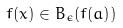Convert formula to latex. <formula><loc_0><loc_0><loc_500><loc_500>f ( x ) \in B _ { \epsilon } ( f ( a ) )</formula> 